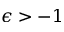Convert formula to latex. <formula><loc_0><loc_0><loc_500><loc_500>\epsilon > - 1</formula> 